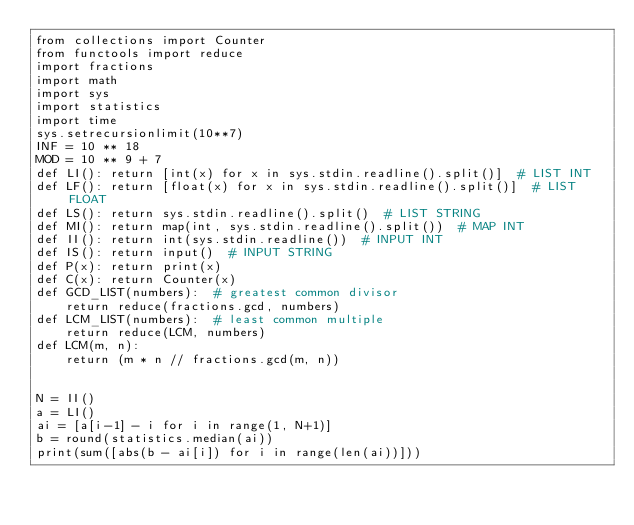<code> <loc_0><loc_0><loc_500><loc_500><_Python_>from collections import Counter
from functools import reduce
import fractions
import math
import sys
import statistics
import time
sys.setrecursionlimit(10**7)
INF = 10 ** 18
MOD = 10 ** 9 + 7
def LI(): return [int(x) for x in sys.stdin.readline().split()]  # LIST INT
def LF(): return [float(x) for x in sys.stdin.readline().split()]  # LIST FLOAT
def LS(): return sys.stdin.readline().split()  # LIST STRING
def MI(): return map(int, sys.stdin.readline().split())  # MAP INT
def II(): return int(sys.stdin.readline())  # INPUT INT
def IS(): return input()  # INPUT STRING
def P(x): return print(x)
def C(x): return Counter(x)
def GCD_LIST(numbers):  # greatest common divisor
    return reduce(fractions.gcd, numbers)
def LCM_LIST(numbers):  # least common multiple
    return reduce(LCM, numbers)
def LCM(m, n):
    return (m * n // fractions.gcd(m, n))


N = II()
a = LI()
ai = [a[i-1] - i for i in range(1, N+1)]
b = round(statistics.median(ai))
print(sum([abs(b - ai[i]) for i in range(len(ai))]))
</code> 